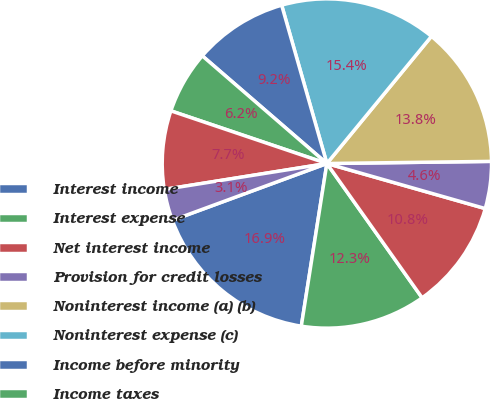<chart> <loc_0><loc_0><loc_500><loc_500><pie_chart><fcel>Interest income<fcel>Interest expense<fcel>Net interest income<fcel>Provision for credit losses<fcel>Noninterest income (a) (b)<fcel>Noninterest expense (c)<fcel>Income before minority<fcel>Income taxes<fcel>Net income (d)<fcel>Book value<nl><fcel>16.91%<fcel>12.3%<fcel>10.77%<fcel>4.62%<fcel>13.84%<fcel>15.38%<fcel>9.23%<fcel>6.16%<fcel>7.7%<fcel>3.09%<nl></chart> 